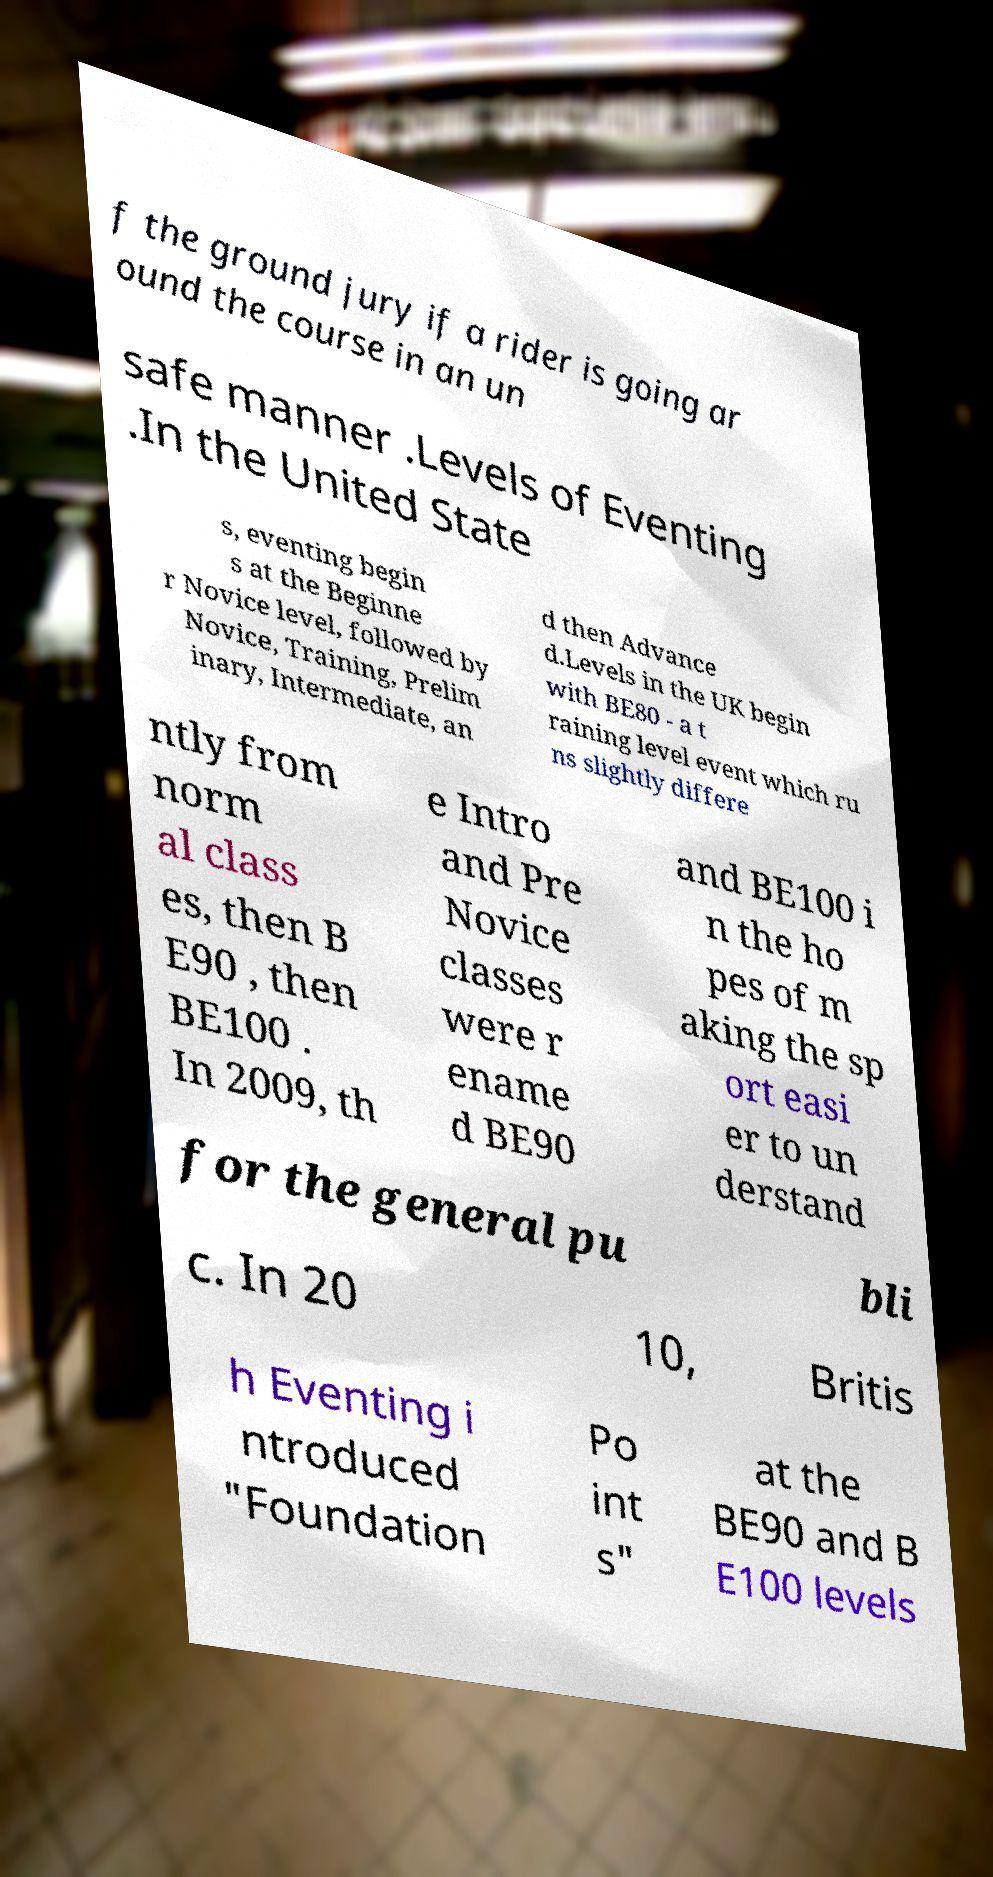There's text embedded in this image that I need extracted. Can you transcribe it verbatim? f the ground jury if a rider is going ar ound the course in an un safe manner .Levels of Eventing .In the United State s, eventing begin s at the Beginne r Novice level, followed by Novice, Training, Prelim inary, Intermediate, an d then Advance d.Levels in the UK begin with BE80 - a t raining level event which ru ns slightly differe ntly from norm al class es, then B E90 , then BE100 . In 2009, th e Intro and Pre Novice classes were r ename d BE90 and BE100 i n the ho pes of m aking the sp ort easi er to un derstand for the general pu bli c. In 20 10, Britis h Eventing i ntroduced "Foundation Po int s" at the BE90 and B E100 levels 